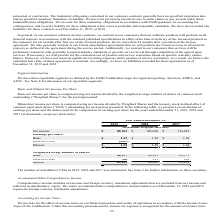According to Manhattan Associates's financial document, What is the net income of 2019? According to the financial document, 85,762 (in thousands). The relevant text states: "Net income $ 85,762 $ 104,690 $ 116,481..." Also, What is the basic number of shares in 2017? According to the financial document, 69,175. The relevant text states: "Basic 64,397 66,201 69,175..." Also, What is the diluted earning per share for 2018? According to the financial document, 1.58. The relevant text states: "Basic $ 1.33 $ 1.58 $ 1.68..." Also, can you calculate: What is change for basic earning per share between 2019 and 2018? Based on the calculation: 1.58-1.33, the result is 0.25. This is based on the information: "Basic $ 1.33 $ 1.58 $ 1.68 Basic $ 1.33 $ 1.58 $ 1.68..." The key data points involved are: 1.33, 1.58. Also, can you calculate: What is the change in number of basic shares between 2017 and 2018? Based on the calculation: 69,175-66,201, the result is 2974. This is based on the information: "Basic 64,397 66,201 69,175 Basic 64,397 66,201 69,175..." The key data points involved are: 66,201, 69,175. Also, can you calculate: What is the change in net income between 2019 and 2018? Based on the calculation: 104,690-85,762, the result is 18928. This is based on the information: "Net income $ 85,762 $ 104,690 $ 116,481 Net income $ 85,762 $ 104,690 $ 116,481..." The key data points involved are: 104,690, 85,762. 